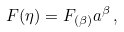<formula> <loc_0><loc_0><loc_500><loc_500>F ( \eta ) = F _ { ( \beta ) } a ^ { \beta } \, ,</formula> 